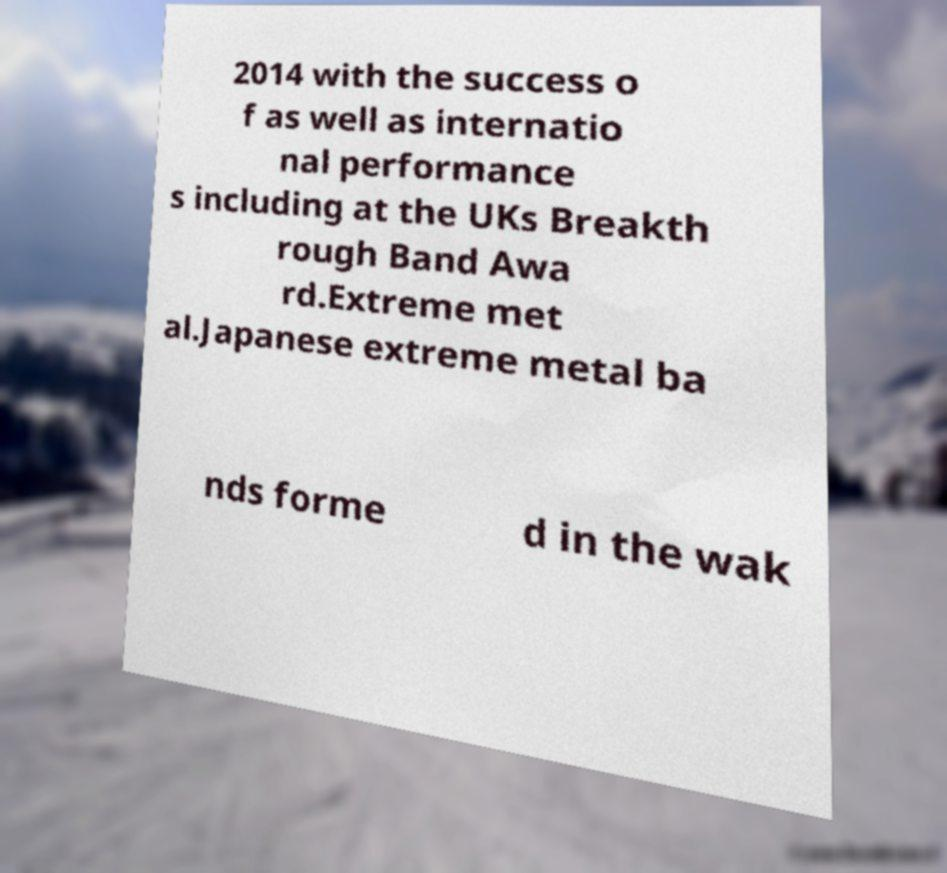What messages or text are displayed in this image? I need them in a readable, typed format. 2014 with the success o f as well as internatio nal performance s including at the UKs Breakth rough Band Awa rd.Extreme met al.Japanese extreme metal ba nds forme d in the wak 